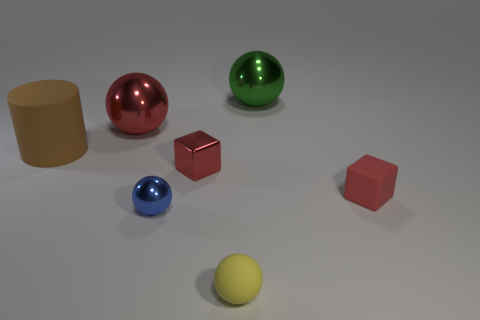There is a large thing that is the same color as the tiny metal block; what shape is it?
Give a very brief answer. Sphere. Is the color of the sphere in front of the small blue ball the same as the block to the right of the green thing?
Provide a succinct answer. No. What size is the ball that is the same color as the metallic block?
Make the answer very short. Large. Are there any tiny red metallic objects?
Your response must be concise. Yes. The red metal object in front of the rubber thing that is on the left side of the small matte object in front of the tiny blue thing is what shape?
Offer a very short reply. Cube. There is a tiny blue metal sphere; how many yellow spheres are left of it?
Keep it short and to the point. 0. Do the block to the left of the tiny red rubber thing and the small yellow object have the same material?
Offer a very short reply. No. How many other objects are the same shape as the green thing?
Your response must be concise. 3. There is a big green shiny object that is behind the blue thing that is on the left side of the big green metal ball; how many metal balls are left of it?
Keep it short and to the point. 2. What color is the large metallic object that is left of the matte sphere?
Your answer should be compact. Red. 